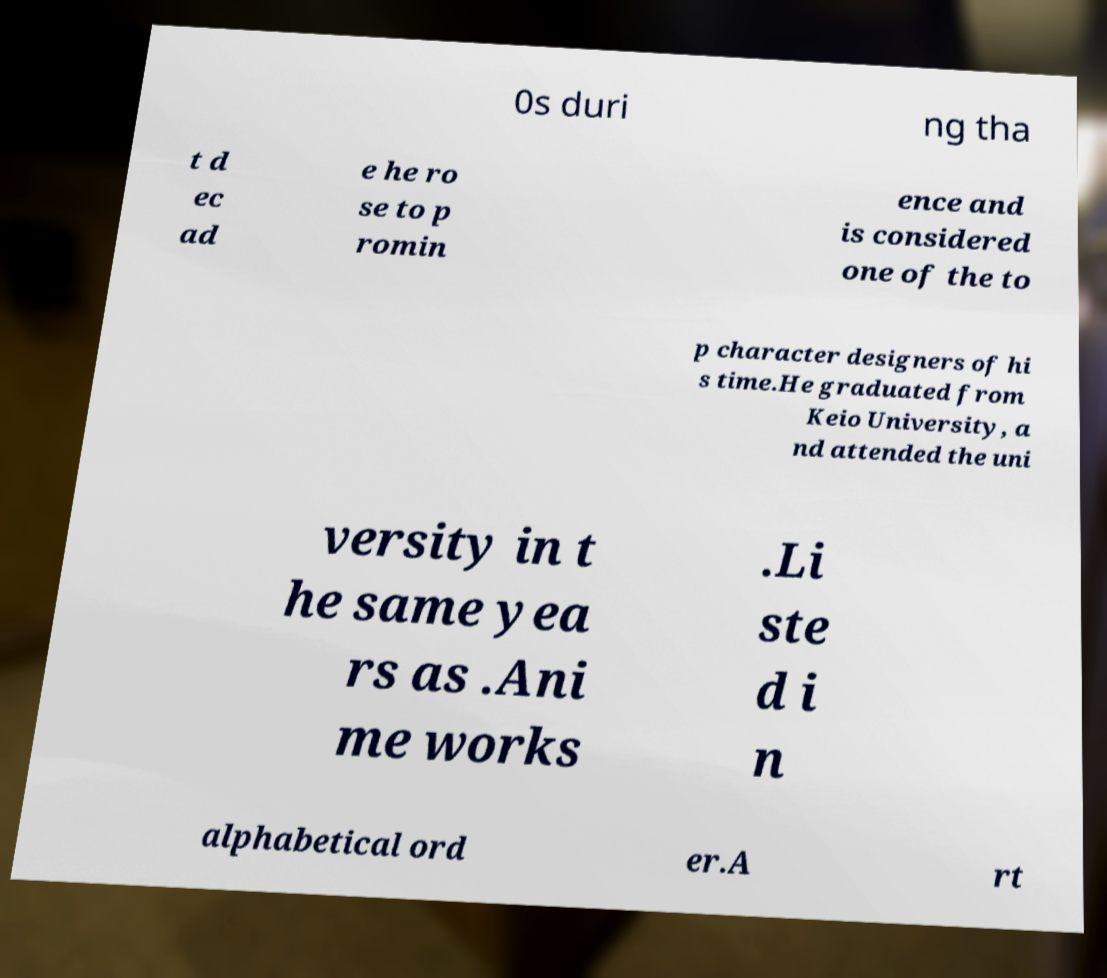I need the written content from this picture converted into text. Can you do that? 0s duri ng tha t d ec ad e he ro se to p romin ence and is considered one of the to p character designers of hi s time.He graduated from Keio University, a nd attended the uni versity in t he same yea rs as .Ani me works .Li ste d i n alphabetical ord er.A rt 